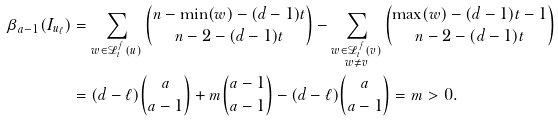Convert formula to latex. <formula><loc_0><loc_0><loc_500><loc_500>\beta _ { a - 1 } ( I _ { u _ { \ell } } ) & = \sum _ { w \in \mathcal { L } _ { t } ^ { f } ( u ) } \binom { n - \min ( w ) - ( d - 1 ) t } { n - 2 - ( d - 1 ) t } - \sum _ { \substack { w \in \mathcal { L } _ { t } ^ { f } ( v ) \\ w \ne v } } \binom { \max ( w ) - ( d - 1 ) t - 1 } { n - 2 - ( d - 1 ) t } \\ & = ( d - \ell ) \binom { a } { a - 1 } + m \binom { a - 1 } { a - 1 } - ( d - \ell ) \binom { a } { a - 1 } = m > 0 .</formula> 